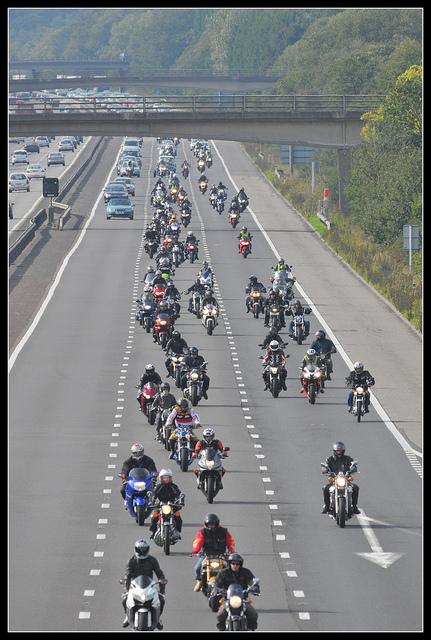How many overpasses are visible?
Write a very short answer. 3. What is this a group of?
Be succinct. Motorcyclists. Where is the arrow?
Give a very brief answer. Street. 